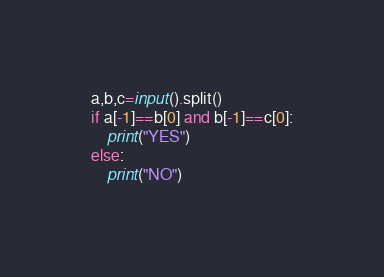Convert code to text. <code><loc_0><loc_0><loc_500><loc_500><_Python_>a,b,c=input().split()
if a[-1]==b[0] and b[-1]==c[0]:
    print("YES")
else:
    print("NO")
</code> 